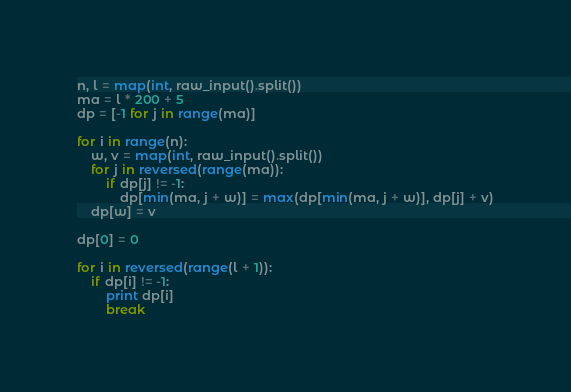<code> <loc_0><loc_0><loc_500><loc_500><_Python_>n, l = map(int, raw_input().split())
ma = l * 200 + 5
dp = [-1 for j in range(ma)]

for i in range(n):
	w, v = map(int, raw_input().split())
	for j in reversed(range(ma)):
		if dp[j] != -1:
			dp[min(ma, j + w)] = max(dp[min(ma, j + w)], dp[j] + v)
	dp[w] = v

dp[0] = 0

for i in reversed(range(l + 1)):
	if dp[i] != -1:
		print dp[i]
		break</code> 